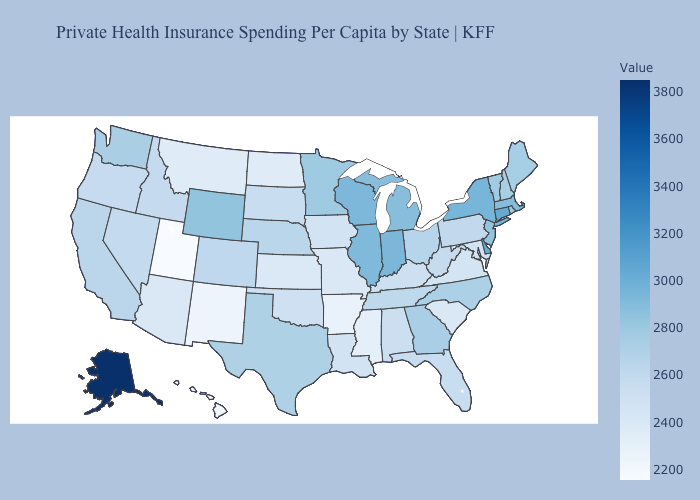Among the states that border Missouri , does Arkansas have the lowest value?
Concise answer only. Yes. Does New York have a lower value than Alaska?
Be succinct. Yes. Does Pennsylvania have a lower value than North Dakota?
Be succinct. No. Which states have the lowest value in the West?
Write a very short answer. Utah. Does Pennsylvania have the highest value in the Northeast?
Answer briefly. No. Does Arkansas have the lowest value in the South?
Be succinct. Yes. Among the states that border Kansas , which have the lowest value?
Concise answer only. Missouri. Which states have the lowest value in the USA?
Write a very short answer. Utah. 